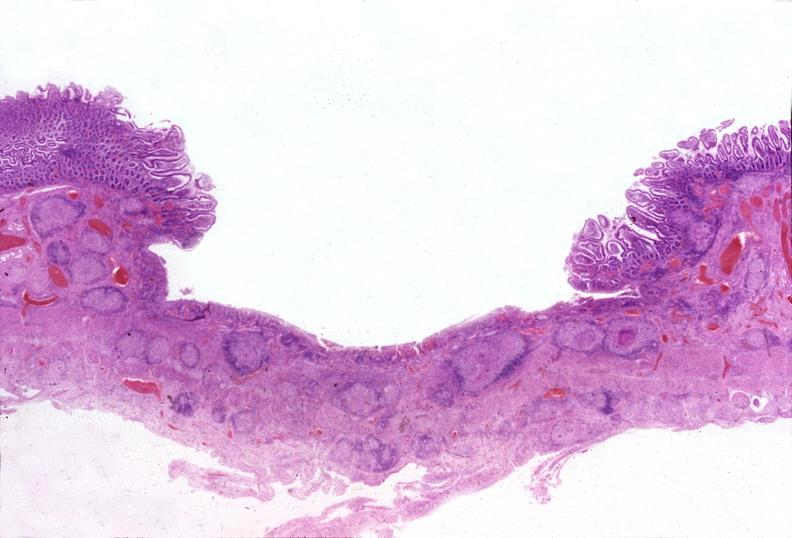s eye present?
Answer the question using a single word or phrase. No 